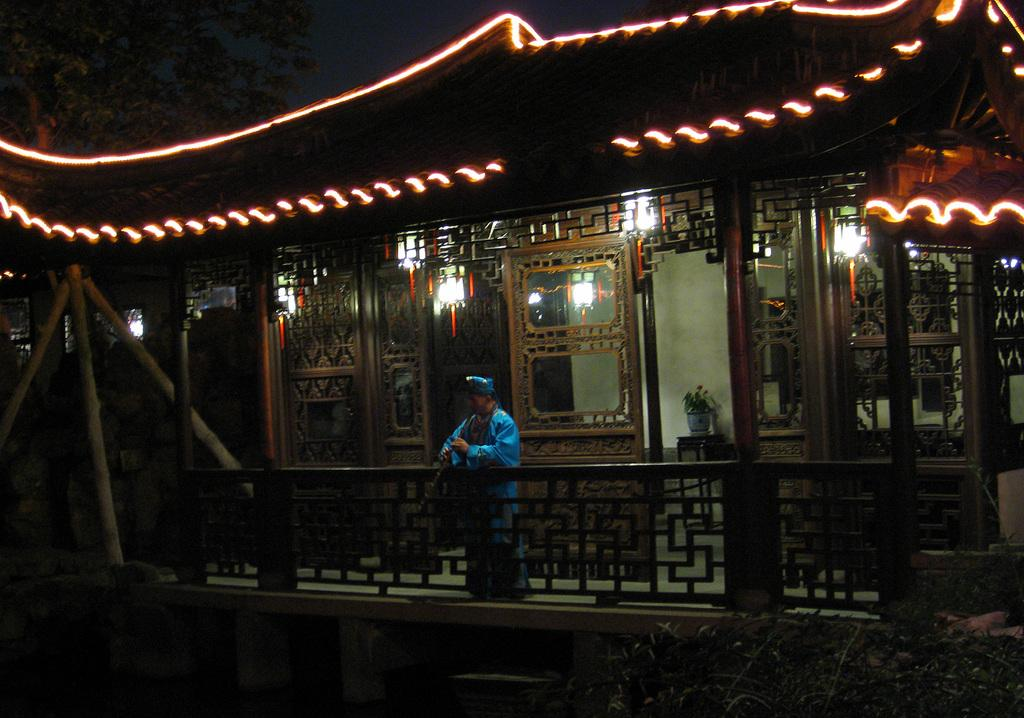What is present in the image? There is a person, a fence, a building, glass doors, light, a tree, the sky, pillars, and poles in the image. Can you describe the person in the image? The person is wearing clothes. What type of structure is visible in the image? There is a building with glass doors, pillars, and poles in the image. What can be seen in the background of the image? The sky and a tree are visible in the background of the image. How many elements can be identified in the image? There are 10 elements identified in the image. What type of addition problem can be solved using the numbers on the poles in the image? There are no numbers on the poles in the image, so it is not possible to solve an addition problem. What shape is the square that the person is standing on in the image? There is no square present in the image; the person is standing on the ground. 